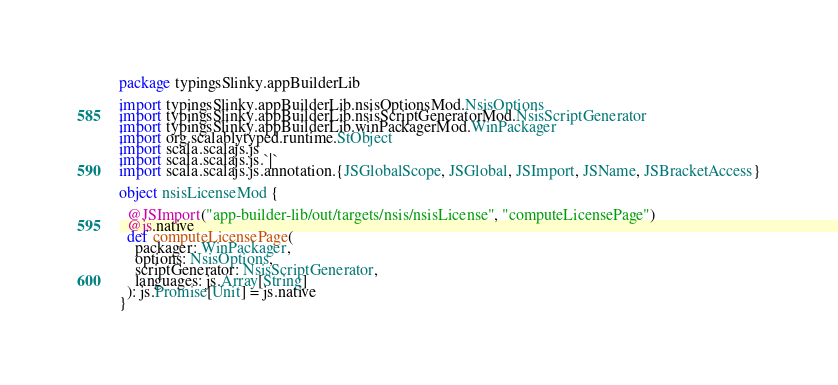Convert code to text. <code><loc_0><loc_0><loc_500><loc_500><_Scala_>package typingsSlinky.appBuilderLib

import typingsSlinky.appBuilderLib.nsisOptionsMod.NsisOptions
import typingsSlinky.appBuilderLib.nsisScriptGeneratorMod.NsisScriptGenerator
import typingsSlinky.appBuilderLib.winPackagerMod.WinPackager
import org.scalablytyped.runtime.StObject
import scala.scalajs.js
import scala.scalajs.js.`|`
import scala.scalajs.js.annotation.{JSGlobalScope, JSGlobal, JSImport, JSName, JSBracketAccess}

object nsisLicenseMod {
  
  @JSImport("app-builder-lib/out/targets/nsis/nsisLicense", "computeLicensePage")
  @js.native
  def computeLicensePage(
    packager: WinPackager,
    options: NsisOptions,
    scriptGenerator: NsisScriptGenerator,
    languages: js.Array[String]
  ): js.Promise[Unit] = js.native
}
</code> 